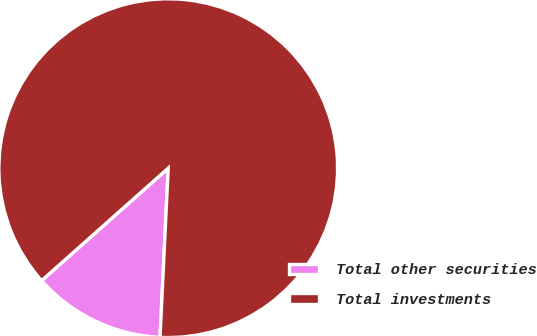Convert chart. <chart><loc_0><loc_0><loc_500><loc_500><pie_chart><fcel>Total other securities<fcel>Total investments<nl><fcel>12.67%<fcel>87.33%<nl></chart> 